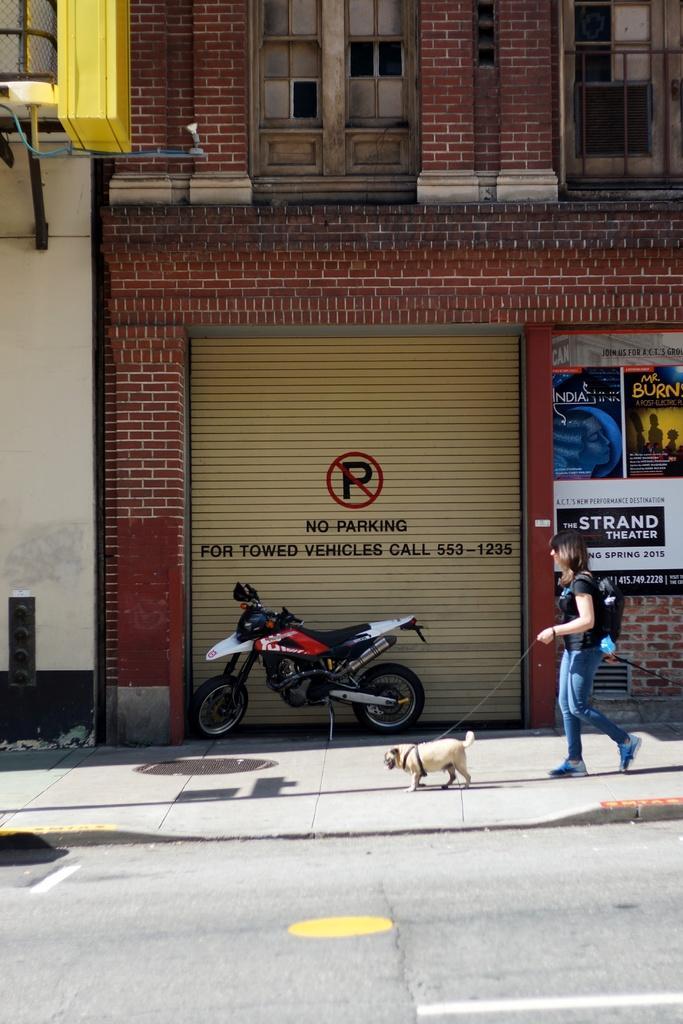Can you describe this image briefly? In this picture I can see there is a woman and a dog, walking on the walkway and there is a building in the backdrop, there is a shutter and there is something written on it. There is a banner on right side and there is a building with windows. 